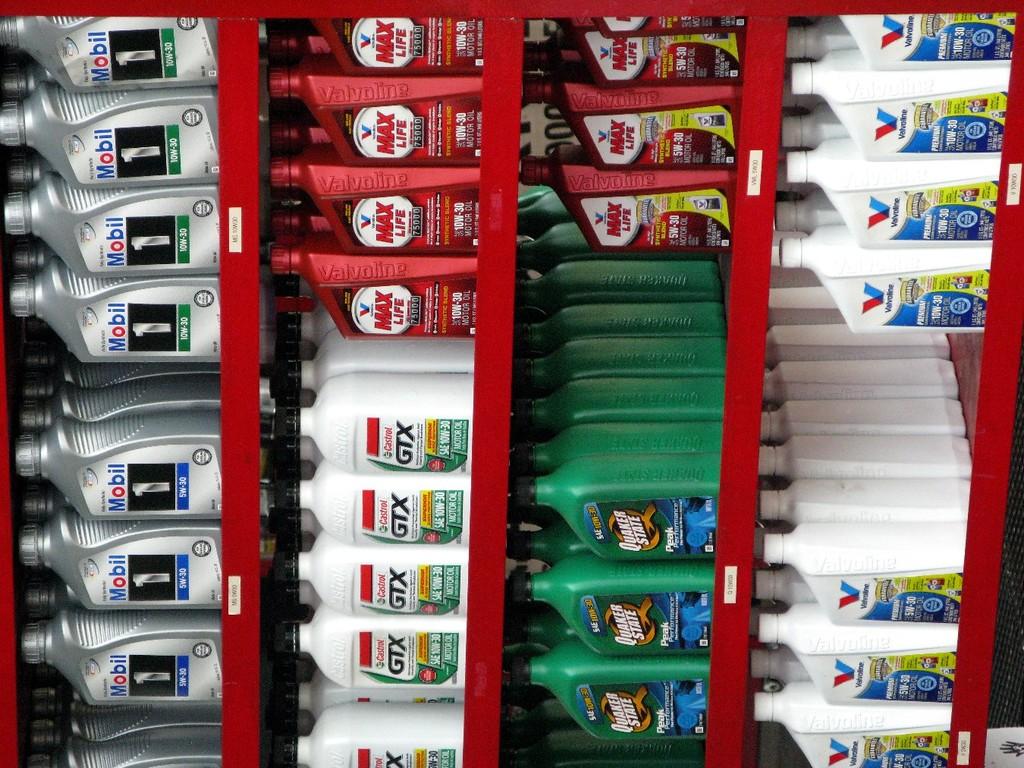What number is on the silver containers?
Keep it short and to the point. 1. 